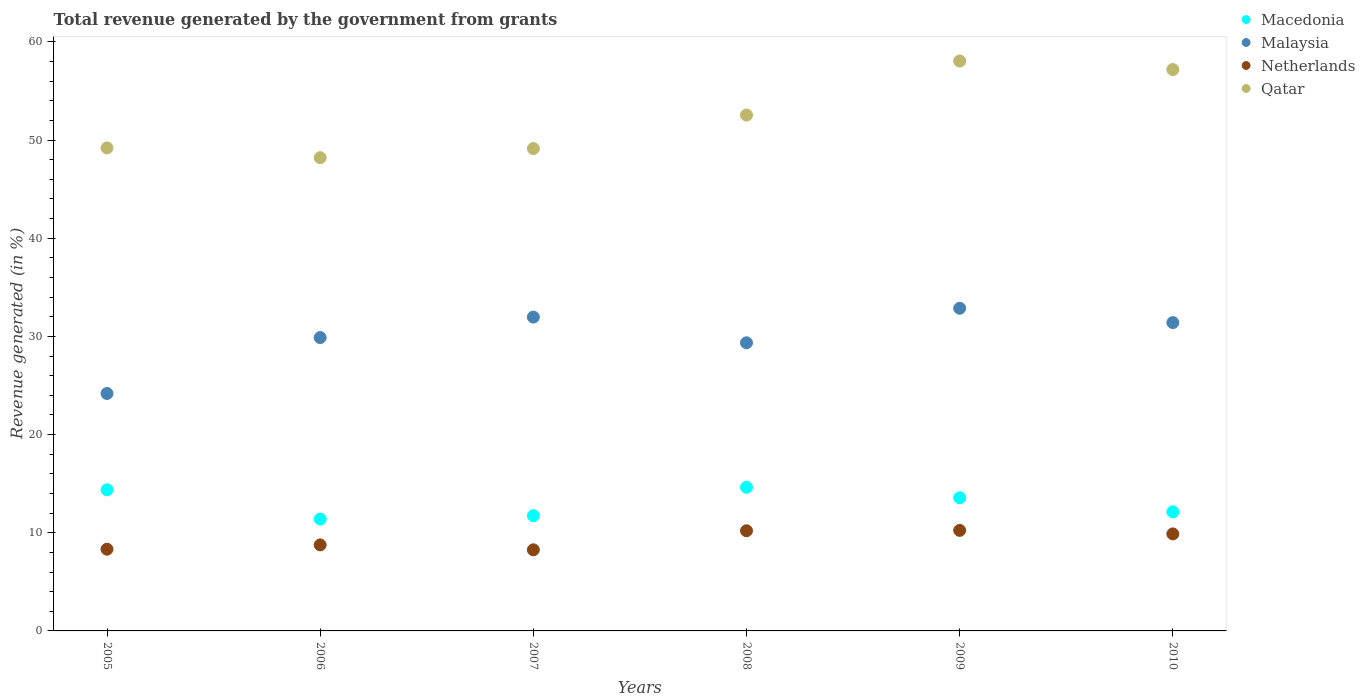What is the total revenue generated in Malaysia in 2009?
Keep it short and to the point. 32.86. Across all years, what is the maximum total revenue generated in Malaysia?
Offer a very short reply. 32.86. Across all years, what is the minimum total revenue generated in Qatar?
Give a very brief answer. 48.2. What is the total total revenue generated in Malaysia in the graph?
Provide a short and direct response. 179.65. What is the difference between the total revenue generated in Netherlands in 2005 and that in 2008?
Provide a short and direct response. -1.88. What is the difference between the total revenue generated in Qatar in 2007 and the total revenue generated in Netherlands in 2009?
Keep it short and to the point. 38.89. What is the average total revenue generated in Macedonia per year?
Make the answer very short. 12.97. In the year 2009, what is the difference between the total revenue generated in Qatar and total revenue generated in Macedonia?
Your answer should be compact. 44.49. In how many years, is the total revenue generated in Malaysia greater than 58 %?
Ensure brevity in your answer.  0. What is the ratio of the total revenue generated in Qatar in 2005 to that in 2010?
Offer a terse response. 0.86. Is the total revenue generated in Malaysia in 2006 less than that in 2008?
Offer a very short reply. No. What is the difference between the highest and the second highest total revenue generated in Malaysia?
Give a very brief answer. 0.9. What is the difference between the highest and the lowest total revenue generated in Malaysia?
Provide a short and direct response. 8.68. Is it the case that in every year, the sum of the total revenue generated in Qatar and total revenue generated in Malaysia  is greater than the sum of total revenue generated in Macedonia and total revenue generated in Netherlands?
Offer a terse response. Yes. Is it the case that in every year, the sum of the total revenue generated in Macedonia and total revenue generated in Malaysia  is greater than the total revenue generated in Qatar?
Ensure brevity in your answer.  No. Is the total revenue generated in Malaysia strictly less than the total revenue generated in Qatar over the years?
Offer a very short reply. Yes. How many dotlines are there?
Keep it short and to the point. 4. How many years are there in the graph?
Ensure brevity in your answer.  6. Are the values on the major ticks of Y-axis written in scientific E-notation?
Your response must be concise. No. Does the graph contain any zero values?
Keep it short and to the point. No. Does the graph contain grids?
Provide a short and direct response. No. What is the title of the graph?
Offer a terse response. Total revenue generated by the government from grants. Does "Guyana" appear as one of the legend labels in the graph?
Offer a very short reply. No. What is the label or title of the Y-axis?
Make the answer very short. Revenue generated (in %). What is the Revenue generated (in %) in Macedonia in 2005?
Your answer should be compact. 14.38. What is the Revenue generated (in %) of Malaysia in 2005?
Offer a very short reply. 24.19. What is the Revenue generated (in %) of Netherlands in 2005?
Ensure brevity in your answer.  8.33. What is the Revenue generated (in %) of Qatar in 2005?
Your response must be concise. 49.2. What is the Revenue generated (in %) of Macedonia in 2006?
Offer a very short reply. 11.39. What is the Revenue generated (in %) of Malaysia in 2006?
Offer a terse response. 29.88. What is the Revenue generated (in %) in Netherlands in 2006?
Give a very brief answer. 8.76. What is the Revenue generated (in %) in Qatar in 2006?
Provide a succinct answer. 48.2. What is the Revenue generated (in %) of Macedonia in 2007?
Your response must be concise. 11.74. What is the Revenue generated (in %) in Malaysia in 2007?
Give a very brief answer. 31.97. What is the Revenue generated (in %) of Netherlands in 2007?
Provide a succinct answer. 8.26. What is the Revenue generated (in %) in Qatar in 2007?
Your response must be concise. 49.13. What is the Revenue generated (in %) in Macedonia in 2008?
Provide a succinct answer. 14.63. What is the Revenue generated (in %) in Malaysia in 2008?
Provide a short and direct response. 29.35. What is the Revenue generated (in %) of Netherlands in 2008?
Make the answer very short. 10.2. What is the Revenue generated (in %) of Qatar in 2008?
Your response must be concise. 52.54. What is the Revenue generated (in %) in Macedonia in 2009?
Provide a short and direct response. 13.56. What is the Revenue generated (in %) in Malaysia in 2009?
Ensure brevity in your answer.  32.86. What is the Revenue generated (in %) of Netherlands in 2009?
Offer a terse response. 10.24. What is the Revenue generated (in %) of Qatar in 2009?
Keep it short and to the point. 58.05. What is the Revenue generated (in %) of Macedonia in 2010?
Offer a very short reply. 12.13. What is the Revenue generated (in %) in Malaysia in 2010?
Give a very brief answer. 31.4. What is the Revenue generated (in %) in Netherlands in 2010?
Provide a succinct answer. 9.88. What is the Revenue generated (in %) of Qatar in 2010?
Your response must be concise. 57.18. Across all years, what is the maximum Revenue generated (in %) in Macedonia?
Make the answer very short. 14.63. Across all years, what is the maximum Revenue generated (in %) in Malaysia?
Your answer should be very brief. 32.86. Across all years, what is the maximum Revenue generated (in %) in Netherlands?
Offer a terse response. 10.24. Across all years, what is the maximum Revenue generated (in %) in Qatar?
Keep it short and to the point. 58.05. Across all years, what is the minimum Revenue generated (in %) in Macedonia?
Offer a terse response. 11.39. Across all years, what is the minimum Revenue generated (in %) of Malaysia?
Your answer should be compact. 24.19. Across all years, what is the minimum Revenue generated (in %) in Netherlands?
Your response must be concise. 8.26. Across all years, what is the minimum Revenue generated (in %) in Qatar?
Provide a succinct answer. 48.2. What is the total Revenue generated (in %) of Macedonia in the graph?
Keep it short and to the point. 77.83. What is the total Revenue generated (in %) in Malaysia in the graph?
Keep it short and to the point. 179.65. What is the total Revenue generated (in %) in Netherlands in the graph?
Offer a terse response. 55.67. What is the total Revenue generated (in %) of Qatar in the graph?
Provide a short and direct response. 314.31. What is the difference between the Revenue generated (in %) in Macedonia in 2005 and that in 2006?
Give a very brief answer. 2.98. What is the difference between the Revenue generated (in %) of Malaysia in 2005 and that in 2006?
Give a very brief answer. -5.69. What is the difference between the Revenue generated (in %) of Netherlands in 2005 and that in 2006?
Give a very brief answer. -0.44. What is the difference between the Revenue generated (in %) in Macedonia in 2005 and that in 2007?
Provide a succinct answer. 2.64. What is the difference between the Revenue generated (in %) in Malaysia in 2005 and that in 2007?
Give a very brief answer. -7.78. What is the difference between the Revenue generated (in %) of Netherlands in 2005 and that in 2007?
Your answer should be very brief. 0.06. What is the difference between the Revenue generated (in %) in Qatar in 2005 and that in 2007?
Make the answer very short. 0.06. What is the difference between the Revenue generated (in %) in Macedonia in 2005 and that in 2008?
Make the answer very short. -0.25. What is the difference between the Revenue generated (in %) of Malaysia in 2005 and that in 2008?
Give a very brief answer. -5.16. What is the difference between the Revenue generated (in %) of Netherlands in 2005 and that in 2008?
Provide a short and direct response. -1.88. What is the difference between the Revenue generated (in %) in Qatar in 2005 and that in 2008?
Make the answer very short. -3.35. What is the difference between the Revenue generated (in %) of Macedonia in 2005 and that in 2009?
Provide a short and direct response. 0.82. What is the difference between the Revenue generated (in %) of Malaysia in 2005 and that in 2009?
Make the answer very short. -8.68. What is the difference between the Revenue generated (in %) of Netherlands in 2005 and that in 2009?
Give a very brief answer. -1.91. What is the difference between the Revenue generated (in %) of Qatar in 2005 and that in 2009?
Offer a terse response. -8.85. What is the difference between the Revenue generated (in %) in Macedonia in 2005 and that in 2010?
Provide a succinct answer. 2.24. What is the difference between the Revenue generated (in %) in Malaysia in 2005 and that in 2010?
Your answer should be compact. -7.22. What is the difference between the Revenue generated (in %) in Netherlands in 2005 and that in 2010?
Your answer should be very brief. -1.56. What is the difference between the Revenue generated (in %) in Qatar in 2005 and that in 2010?
Your answer should be compact. -7.98. What is the difference between the Revenue generated (in %) of Macedonia in 2006 and that in 2007?
Keep it short and to the point. -0.35. What is the difference between the Revenue generated (in %) of Malaysia in 2006 and that in 2007?
Your answer should be very brief. -2.09. What is the difference between the Revenue generated (in %) of Netherlands in 2006 and that in 2007?
Keep it short and to the point. 0.5. What is the difference between the Revenue generated (in %) in Qatar in 2006 and that in 2007?
Provide a succinct answer. -0.93. What is the difference between the Revenue generated (in %) of Macedonia in 2006 and that in 2008?
Make the answer very short. -3.24. What is the difference between the Revenue generated (in %) in Malaysia in 2006 and that in 2008?
Offer a terse response. 0.53. What is the difference between the Revenue generated (in %) of Netherlands in 2006 and that in 2008?
Your answer should be very brief. -1.44. What is the difference between the Revenue generated (in %) in Qatar in 2006 and that in 2008?
Ensure brevity in your answer.  -4.34. What is the difference between the Revenue generated (in %) of Macedonia in 2006 and that in 2009?
Make the answer very short. -2.17. What is the difference between the Revenue generated (in %) of Malaysia in 2006 and that in 2009?
Make the answer very short. -2.98. What is the difference between the Revenue generated (in %) in Netherlands in 2006 and that in 2009?
Your answer should be compact. -1.48. What is the difference between the Revenue generated (in %) in Qatar in 2006 and that in 2009?
Make the answer very short. -9.85. What is the difference between the Revenue generated (in %) of Macedonia in 2006 and that in 2010?
Your answer should be compact. -0.74. What is the difference between the Revenue generated (in %) in Malaysia in 2006 and that in 2010?
Provide a succinct answer. -1.52. What is the difference between the Revenue generated (in %) of Netherlands in 2006 and that in 2010?
Your answer should be very brief. -1.12. What is the difference between the Revenue generated (in %) of Qatar in 2006 and that in 2010?
Your answer should be very brief. -8.98. What is the difference between the Revenue generated (in %) of Macedonia in 2007 and that in 2008?
Provide a short and direct response. -2.89. What is the difference between the Revenue generated (in %) of Malaysia in 2007 and that in 2008?
Offer a terse response. 2.62. What is the difference between the Revenue generated (in %) in Netherlands in 2007 and that in 2008?
Provide a succinct answer. -1.94. What is the difference between the Revenue generated (in %) of Qatar in 2007 and that in 2008?
Keep it short and to the point. -3.41. What is the difference between the Revenue generated (in %) in Macedonia in 2007 and that in 2009?
Offer a very short reply. -1.82. What is the difference between the Revenue generated (in %) in Malaysia in 2007 and that in 2009?
Keep it short and to the point. -0.9. What is the difference between the Revenue generated (in %) of Netherlands in 2007 and that in 2009?
Give a very brief answer. -1.98. What is the difference between the Revenue generated (in %) in Qatar in 2007 and that in 2009?
Offer a terse response. -8.92. What is the difference between the Revenue generated (in %) in Macedonia in 2007 and that in 2010?
Give a very brief answer. -0.39. What is the difference between the Revenue generated (in %) in Malaysia in 2007 and that in 2010?
Your answer should be compact. 0.56. What is the difference between the Revenue generated (in %) in Netherlands in 2007 and that in 2010?
Provide a succinct answer. -1.62. What is the difference between the Revenue generated (in %) of Qatar in 2007 and that in 2010?
Keep it short and to the point. -8.05. What is the difference between the Revenue generated (in %) in Macedonia in 2008 and that in 2009?
Your answer should be compact. 1.07. What is the difference between the Revenue generated (in %) in Malaysia in 2008 and that in 2009?
Provide a short and direct response. -3.52. What is the difference between the Revenue generated (in %) of Netherlands in 2008 and that in 2009?
Give a very brief answer. -0.04. What is the difference between the Revenue generated (in %) of Qatar in 2008 and that in 2009?
Your response must be concise. -5.51. What is the difference between the Revenue generated (in %) in Macedonia in 2008 and that in 2010?
Your answer should be compact. 2.5. What is the difference between the Revenue generated (in %) of Malaysia in 2008 and that in 2010?
Provide a succinct answer. -2.06. What is the difference between the Revenue generated (in %) in Netherlands in 2008 and that in 2010?
Ensure brevity in your answer.  0.32. What is the difference between the Revenue generated (in %) in Qatar in 2008 and that in 2010?
Provide a short and direct response. -4.64. What is the difference between the Revenue generated (in %) of Macedonia in 2009 and that in 2010?
Keep it short and to the point. 1.43. What is the difference between the Revenue generated (in %) of Malaysia in 2009 and that in 2010?
Provide a succinct answer. 1.46. What is the difference between the Revenue generated (in %) in Netherlands in 2009 and that in 2010?
Make the answer very short. 0.36. What is the difference between the Revenue generated (in %) in Qatar in 2009 and that in 2010?
Give a very brief answer. 0.87. What is the difference between the Revenue generated (in %) in Macedonia in 2005 and the Revenue generated (in %) in Malaysia in 2006?
Your response must be concise. -15.5. What is the difference between the Revenue generated (in %) of Macedonia in 2005 and the Revenue generated (in %) of Netherlands in 2006?
Make the answer very short. 5.61. What is the difference between the Revenue generated (in %) in Macedonia in 2005 and the Revenue generated (in %) in Qatar in 2006?
Provide a short and direct response. -33.83. What is the difference between the Revenue generated (in %) in Malaysia in 2005 and the Revenue generated (in %) in Netherlands in 2006?
Offer a terse response. 15.42. What is the difference between the Revenue generated (in %) in Malaysia in 2005 and the Revenue generated (in %) in Qatar in 2006?
Offer a terse response. -24.02. What is the difference between the Revenue generated (in %) of Netherlands in 2005 and the Revenue generated (in %) of Qatar in 2006?
Provide a succinct answer. -39.88. What is the difference between the Revenue generated (in %) of Macedonia in 2005 and the Revenue generated (in %) of Malaysia in 2007?
Provide a succinct answer. -17.59. What is the difference between the Revenue generated (in %) in Macedonia in 2005 and the Revenue generated (in %) in Netherlands in 2007?
Offer a very short reply. 6.11. What is the difference between the Revenue generated (in %) of Macedonia in 2005 and the Revenue generated (in %) of Qatar in 2007?
Give a very brief answer. -34.76. What is the difference between the Revenue generated (in %) in Malaysia in 2005 and the Revenue generated (in %) in Netherlands in 2007?
Provide a succinct answer. 15.92. What is the difference between the Revenue generated (in %) of Malaysia in 2005 and the Revenue generated (in %) of Qatar in 2007?
Your answer should be compact. -24.95. What is the difference between the Revenue generated (in %) in Netherlands in 2005 and the Revenue generated (in %) in Qatar in 2007?
Provide a short and direct response. -40.81. What is the difference between the Revenue generated (in %) of Macedonia in 2005 and the Revenue generated (in %) of Malaysia in 2008?
Give a very brief answer. -14.97. What is the difference between the Revenue generated (in %) in Macedonia in 2005 and the Revenue generated (in %) in Netherlands in 2008?
Keep it short and to the point. 4.17. What is the difference between the Revenue generated (in %) of Macedonia in 2005 and the Revenue generated (in %) of Qatar in 2008?
Give a very brief answer. -38.17. What is the difference between the Revenue generated (in %) in Malaysia in 2005 and the Revenue generated (in %) in Netherlands in 2008?
Provide a succinct answer. 13.98. What is the difference between the Revenue generated (in %) in Malaysia in 2005 and the Revenue generated (in %) in Qatar in 2008?
Give a very brief answer. -28.36. What is the difference between the Revenue generated (in %) in Netherlands in 2005 and the Revenue generated (in %) in Qatar in 2008?
Give a very brief answer. -44.22. What is the difference between the Revenue generated (in %) in Macedonia in 2005 and the Revenue generated (in %) in Malaysia in 2009?
Ensure brevity in your answer.  -18.49. What is the difference between the Revenue generated (in %) of Macedonia in 2005 and the Revenue generated (in %) of Netherlands in 2009?
Provide a short and direct response. 4.14. What is the difference between the Revenue generated (in %) in Macedonia in 2005 and the Revenue generated (in %) in Qatar in 2009?
Your answer should be very brief. -43.67. What is the difference between the Revenue generated (in %) of Malaysia in 2005 and the Revenue generated (in %) of Netherlands in 2009?
Your response must be concise. 13.95. What is the difference between the Revenue generated (in %) in Malaysia in 2005 and the Revenue generated (in %) in Qatar in 2009?
Provide a succinct answer. -33.86. What is the difference between the Revenue generated (in %) of Netherlands in 2005 and the Revenue generated (in %) of Qatar in 2009?
Provide a short and direct response. -49.72. What is the difference between the Revenue generated (in %) in Macedonia in 2005 and the Revenue generated (in %) in Malaysia in 2010?
Your response must be concise. -17.03. What is the difference between the Revenue generated (in %) of Macedonia in 2005 and the Revenue generated (in %) of Netherlands in 2010?
Provide a succinct answer. 4.49. What is the difference between the Revenue generated (in %) in Macedonia in 2005 and the Revenue generated (in %) in Qatar in 2010?
Provide a short and direct response. -42.8. What is the difference between the Revenue generated (in %) in Malaysia in 2005 and the Revenue generated (in %) in Netherlands in 2010?
Make the answer very short. 14.3. What is the difference between the Revenue generated (in %) of Malaysia in 2005 and the Revenue generated (in %) of Qatar in 2010?
Your answer should be compact. -32.99. What is the difference between the Revenue generated (in %) in Netherlands in 2005 and the Revenue generated (in %) in Qatar in 2010?
Provide a succinct answer. -48.86. What is the difference between the Revenue generated (in %) of Macedonia in 2006 and the Revenue generated (in %) of Malaysia in 2007?
Your answer should be compact. -20.57. What is the difference between the Revenue generated (in %) in Macedonia in 2006 and the Revenue generated (in %) in Netherlands in 2007?
Provide a short and direct response. 3.13. What is the difference between the Revenue generated (in %) in Macedonia in 2006 and the Revenue generated (in %) in Qatar in 2007?
Give a very brief answer. -37.74. What is the difference between the Revenue generated (in %) in Malaysia in 2006 and the Revenue generated (in %) in Netherlands in 2007?
Offer a very short reply. 21.62. What is the difference between the Revenue generated (in %) of Malaysia in 2006 and the Revenue generated (in %) of Qatar in 2007?
Make the answer very short. -19.25. What is the difference between the Revenue generated (in %) in Netherlands in 2006 and the Revenue generated (in %) in Qatar in 2007?
Your answer should be very brief. -40.37. What is the difference between the Revenue generated (in %) of Macedonia in 2006 and the Revenue generated (in %) of Malaysia in 2008?
Your response must be concise. -17.96. What is the difference between the Revenue generated (in %) in Macedonia in 2006 and the Revenue generated (in %) in Netherlands in 2008?
Give a very brief answer. 1.19. What is the difference between the Revenue generated (in %) in Macedonia in 2006 and the Revenue generated (in %) in Qatar in 2008?
Give a very brief answer. -41.15. What is the difference between the Revenue generated (in %) of Malaysia in 2006 and the Revenue generated (in %) of Netherlands in 2008?
Keep it short and to the point. 19.68. What is the difference between the Revenue generated (in %) in Malaysia in 2006 and the Revenue generated (in %) in Qatar in 2008?
Offer a terse response. -22.66. What is the difference between the Revenue generated (in %) in Netherlands in 2006 and the Revenue generated (in %) in Qatar in 2008?
Make the answer very short. -43.78. What is the difference between the Revenue generated (in %) of Macedonia in 2006 and the Revenue generated (in %) of Malaysia in 2009?
Your answer should be very brief. -21.47. What is the difference between the Revenue generated (in %) of Macedonia in 2006 and the Revenue generated (in %) of Netherlands in 2009?
Ensure brevity in your answer.  1.15. What is the difference between the Revenue generated (in %) of Macedonia in 2006 and the Revenue generated (in %) of Qatar in 2009?
Offer a very short reply. -46.66. What is the difference between the Revenue generated (in %) in Malaysia in 2006 and the Revenue generated (in %) in Netherlands in 2009?
Provide a short and direct response. 19.64. What is the difference between the Revenue generated (in %) in Malaysia in 2006 and the Revenue generated (in %) in Qatar in 2009?
Offer a terse response. -28.17. What is the difference between the Revenue generated (in %) in Netherlands in 2006 and the Revenue generated (in %) in Qatar in 2009?
Provide a succinct answer. -49.29. What is the difference between the Revenue generated (in %) of Macedonia in 2006 and the Revenue generated (in %) of Malaysia in 2010?
Provide a short and direct response. -20.01. What is the difference between the Revenue generated (in %) of Macedonia in 2006 and the Revenue generated (in %) of Netherlands in 2010?
Give a very brief answer. 1.51. What is the difference between the Revenue generated (in %) of Macedonia in 2006 and the Revenue generated (in %) of Qatar in 2010?
Provide a short and direct response. -45.79. What is the difference between the Revenue generated (in %) of Malaysia in 2006 and the Revenue generated (in %) of Netherlands in 2010?
Offer a terse response. 20. What is the difference between the Revenue generated (in %) of Malaysia in 2006 and the Revenue generated (in %) of Qatar in 2010?
Provide a succinct answer. -27.3. What is the difference between the Revenue generated (in %) in Netherlands in 2006 and the Revenue generated (in %) in Qatar in 2010?
Make the answer very short. -48.42. What is the difference between the Revenue generated (in %) in Macedonia in 2007 and the Revenue generated (in %) in Malaysia in 2008?
Make the answer very short. -17.61. What is the difference between the Revenue generated (in %) in Macedonia in 2007 and the Revenue generated (in %) in Netherlands in 2008?
Give a very brief answer. 1.54. What is the difference between the Revenue generated (in %) in Macedonia in 2007 and the Revenue generated (in %) in Qatar in 2008?
Your response must be concise. -40.81. What is the difference between the Revenue generated (in %) of Malaysia in 2007 and the Revenue generated (in %) of Netherlands in 2008?
Offer a very short reply. 21.77. What is the difference between the Revenue generated (in %) of Malaysia in 2007 and the Revenue generated (in %) of Qatar in 2008?
Keep it short and to the point. -20.58. What is the difference between the Revenue generated (in %) in Netherlands in 2007 and the Revenue generated (in %) in Qatar in 2008?
Ensure brevity in your answer.  -44.28. What is the difference between the Revenue generated (in %) of Macedonia in 2007 and the Revenue generated (in %) of Malaysia in 2009?
Make the answer very short. -21.13. What is the difference between the Revenue generated (in %) in Macedonia in 2007 and the Revenue generated (in %) in Netherlands in 2009?
Give a very brief answer. 1.5. What is the difference between the Revenue generated (in %) in Macedonia in 2007 and the Revenue generated (in %) in Qatar in 2009?
Offer a terse response. -46.31. What is the difference between the Revenue generated (in %) of Malaysia in 2007 and the Revenue generated (in %) of Netherlands in 2009?
Offer a very short reply. 21.73. What is the difference between the Revenue generated (in %) in Malaysia in 2007 and the Revenue generated (in %) in Qatar in 2009?
Provide a short and direct response. -26.08. What is the difference between the Revenue generated (in %) of Netherlands in 2007 and the Revenue generated (in %) of Qatar in 2009?
Provide a succinct answer. -49.79. What is the difference between the Revenue generated (in %) in Macedonia in 2007 and the Revenue generated (in %) in Malaysia in 2010?
Offer a very short reply. -19.67. What is the difference between the Revenue generated (in %) of Macedonia in 2007 and the Revenue generated (in %) of Netherlands in 2010?
Offer a very short reply. 1.85. What is the difference between the Revenue generated (in %) of Macedonia in 2007 and the Revenue generated (in %) of Qatar in 2010?
Offer a very short reply. -45.44. What is the difference between the Revenue generated (in %) in Malaysia in 2007 and the Revenue generated (in %) in Netherlands in 2010?
Ensure brevity in your answer.  22.08. What is the difference between the Revenue generated (in %) in Malaysia in 2007 and the Revenue generated (in %) in Qatar in 2010?
Offer a terse response. -25.21. What is the difference between the Revenue generated (in %) in Netherlands in 2007 and the Revenue generated (in %) in Qatar in 2010?
Offer a very short reply. -48.92. What is the difference between the Revenue generated (in %) of Macedonia in 2008 and the Revenue generated (in %) of Malaysia in 2009?
Give a very brief answer. -18.23. What is the difference between the Revenue generated (in %) in Macedonia in 2008 and the Revenue generated (in %) in Netherlands in 2009?
Your answer should be compact. 4.39. What is the difference between the Revenue generated (in %) in Macedonia in 2008 and the Revenue generated (in %) in Qatar in 2009?
Give a very brief answer. -43.42. What is the difference between the Revenue generated (in %) in Malaysia in 2008 and the Revenue generated (in %) in Netherlands in 2009?
Make the answer very short. 19.11. What is the difference between the Revenue generated (in %) of Malaysia in 2008 and the Revenue generated (in %) of Qatar in 2009?
Your answer should be very brief. -28.7. What is the difference between the Revenue generated (in %) in Netherlands in 2008 and the Revenue generated (in %) in Qatar in 2009?
Provide a short and direct response. -47.85. What is the difference between the Revenue generated (in %) in Macedonia in 2008 and the Revenue generated (in %) in Malaysia in 2010?
Give a very brief answer. -16.77. What is the difference between the Revenue generated (in %) in Macedonia in 2008 and the Revenue generated (in %) in Netherlands in 2010?
Make the answer very short. 4.75. What is the difference between the Revenue generated (in %) of Macedonia in 2008 and the Revenue generated (in %) of Qatar in 2010?
Your response must be concise. -42.55. What is the difference between the Revenue generated (in %) of Malaysia in 2008 and the Revenue generated (in %) of Netherlands in 2010?
Offer a terse response. 19.47. What is the difference between the Revenue generated (in %) of Malaysia in 2008 and the Revenue generated (in %) of Qatar in 2010?
Your answer should be very brief. -27.83. What is the difference between the Revenue generated (in %) of Netherlands in 2008 and the Revenue generated (in %) of Qatar in 2010?
Provide a short and direct response. -46.98. What is the difference between the Revenue generated (in %) of Macedonia in 2009 and the Revenue generated (in %) of Malaysia in 2010?
Keep it short and to the point. -17.84. What is the difference between the Revenue generated (in %) in Macedonia in 2009 and the Revenue generated (in %) in Netherlands in 2010?
Offer a very short reply. 3.68. What is the difference between the Revenue generated (in %) of Macedonia in 2009 and the Revenue generated (in %) of Qatar in 2010?
Offer a terse response. -43.62. What is the difference between the Revenue generated (in %) in Malaysia in 2009 and the Revenue generated (in %) in Netherlands in 2010?
Keep it short and to the point. 22.98. What is the difference between the Revenue generated (in %) in Malaysia in 2009 and the Revenue generated (in %) in Qatar in 2010?
Ensure brevity in your answer.  -24.32. What is the difference between the Revenue generated (in %) of Netherlands in 2009 and the Revenue generated (in %) of Qatar in 2010?
Give a very brief answer. -46.94. What is the average Revenue generated (in %) in Macedonia per year?
Keep it short and to the point. 12.97. What is the average Revenue generated (in %) of Malaysia per year?
Make the answer very short. 29.94. What is the average Revenue generated (in %) in Netherlands per year?
Provide a succinct answer. 9.28. What is the average Revenue generated (in %) in Qatar per year?
Offer a very short reply. 52.38. In the year 2005, what is the difference between the Revenue generated (in %) in Macedonia and Revenue generated (in %) in Malaysia?
Make the answer very short. -9.81. In the year 2005, what is the difference between the Revenue generated (in %) of Macedonia and Revenue generated (in %) of Netherlands?
Your answer should be compact. 6.05. In the year 2005, what is the difference between the Revenue generated (in %) of Macedonia and Revenue generated (in %) of Qatar?
Provide a short and direct response. -34.82. In the year 2005, what is the difference between the Revenue generated (in %) of Malaysia and Revenue generated (in %) of Netherlands?
Give a very brief answer. 15.86. In the year 2005, what is the difference between the Revenue generated (in %) in Malaysia and Revenue generated (in %) in Qatar?
Give a very brief answer. -25.01. In the year 2005, what is the difference between the Revenue generated (in %) of Netherlands and Revenue generated (in %) of Qatar?
Give a very brief answer. -40.87. In the year 2006, what is the difference between the Revenue generated (in %) of Macedonia and Revenue generated (in %) of Malaysia?
Provide a succinct answer. -18.49. In the year 2006, what is the difference between the Revenue generated (in %) in Macedonia and Revenue generated (in %) in Netherlands?
Your answer should be very brief. 2.63. In the year 2006, what is the difference between the Revenue generated (in %) of Macedonia and Revenue generated (in %) of Qatar?
Give a very brief answer. -36.81. In the year 2006, what is the difference between the Revenue generated (in %) in Malaysia and Revenue generated (in %) in Netherlands?
Offer a terse response. 21.12. In the year 2006, what is the difference between the Revenue generated (in %) in Malaysia and Revenue generated (in %) in Qatar?
Your answer should be very brief. -18.32. In the year 2006, what is the difference between the Revenue generated (in %) in Netherlands and Revenue generated (in %) in Qatar?
Make the answer very short. -39.44. In the year 2007, what is the difference between the Revenue generated (in %) of Macedonia and Revenue generated (in %) of Malaysia?
Provide a succinct answer. -20.23. In the year 2007, what is the difference between the Revenue generated (in %) of Macedonia and Revenue generated (in %) of Netherlands?
Your answer should be very brief. 3.48. In the year 2007, what is the difference between the Revenue generated (in %) of Macedonia and Revenue generated (in %) of Qatar?
Give a very brief answer. -37.4. In the year 2007, what is the difference between the Revenue generated (in %) of Malaysia and Revenue generated (in %) of Netherlands?
Your response must be concise. 23.71. In the year 2007, what is the difference between the Revenue generated (in %) in Malaysia and Revenue generated (in %) in Qatar?
Provide a succinct answer. -17.17. In the year 2007, what is the difference between the Revenue generated (in %) of Netherlands and Revenue generated (in %) of Qatar?
Provide a short and direct response. -40.87. In the year 2008, what is the difference between the Revenue generated (in %) of Macedonia and Revenue generated (in %) of Malaysia?
Keep it short and to the point. -14.72. In the year 2008, what is the difference between the Revenue generated (in %) of Macedonia and Revenue generated (in %) of Netherlands?
Ensure brevity in your answer.  4.43. In the year 2008, what is the difference between the Revenue generated (in %) in Macedonia and Revenue generated (in %) in Qatar?
Your answer should be very brief. -37.91. In the year 2008, what is the difference between the Revenue generated (in %) of Malaysia and Revenue generated (in %) of Netherlands?
Keep it short and to the point. 19.15. In the year 2008, what is the difference between the Revenue generated (in %) in Malaysia and Revenue generated (in %) in Qatar?
Provide a short and direct response. -23.2. In the year 2008, what is the difference between the Revenue generated (in %) in Netherlands and Revenue generated (in %) in Qatar?
Give a very brief answer. -42.34. In the year 2009, what is the difference between the Revenue generated (in %) of Macedonia and Revenue generated (in %) of Malaysia?
Your answer should be very brief. -19.3. In the year 2009, what is the difference between the Revenue generated (in %) of Macedonia and Revenue generated (in %) of Netherlands?
Provide a short and direct response. 3.32. In the year 2009, what is the difference between the Revenue generated (in %) in Macedonia and Revenue generated (in %) in Qatar?
Your answer should be very brief. -44.49. In the year 2009, what is the difference between the Revenue generated (in %) of Malaysia and Revenue generated (in %) of Netherlands?
Your response must be concise. 22.62. In the year 2009, what is the difference between the Revenue generated (in %) in Malaysia and Revenue generated (in %) in Qatar?
Offer a very short reply. -25.19. In the year 2009, what is the difference between the Revenue generated (in %) in Netherlands and Revenue generated (in %) in Qatar?
Give a very brief answer. -47.81. In the year 2010, what is the difference between the Revenue generated (in %) in Macedonia and Revenue generated (in %) in Malaysia?
Give a very brief answer. -19.27. In the year 2010, what is the difference between the Revenue generated (in %) of Macedonia and Revenue generated (in %) of Netherlands?
Your answer should be compact. 2.25. In the year 2010, what is the difference between the Revenue generated (in %) of Macedonia and Revenue generated (in %) of Qatar?
Your answer should be very brief. -45.05. In the year 2010, what is the difference between the Revenue generated (in %) of Malaysia and Revenue generated (in %) of Netherlands?
Keep it short and to the point. 21.52. In the year 2010, what is the difference between the Revenue generated (in %) in Malaysia and Revenue generated (in %) in Qatar?
Offer a terse response. -25.78. In the year 2010, what is the difference between the Revenue generated (in %) in Netherlands and Revenue generated (in %) in Qatar?
Keep it short and to the point. -47.3. What is the ratio of the Revenue generated (in %) of Macedonia in 2005 to that in 2006?
Your answer should be compact. 1.26. What is the ratio of the Revenue generated (in %) of Malaysia in 2005 to that in 2006?
Provide a succinct answer. 0.81. What is the ratio of the Revenue generated (in %) in Netherlands in 2005 to that in 2006?
Keep it short and to the point. 0.95. What is the ratio of the Revenue generated (in %) of Qatar in 2005 to that in 2006?
Provide a succinct answer. 1.02. What is the ratio of the Revenue generated (in %) in Macedonia in 2005 to that in 2007?
Your answer should be compact. 1.22. What is the ratio of the Revenue generated (in %) of Malaysia in 2005 to that in 2007?
Your response must be concise. 0.76. What is the ratio of the Revenue generated (in %) in Netherlands in 2005 to that in 2007?
Your response must be concise. 1.01. What is the ratio of the Revenue generated (in %) in Macedonia in 2005 to that in 2008?
Provide a succinct answer. 0.98. What is the ratio of the Revenue generated (in %) of Malaysia in 2005 to that in 2008?
Your answer should be very brief. 0.82. What is the ratio of the Revenue generated (in %) in Netherlands in 2005 to that in 2008?
Your answer should be very brief. 0.82. What is the ratio of the Revenue generated (in %) in Qatar in 2005 to that in 2008?
Your answer should be compact. 0.94. What is the ratio of the Revenue generated (in %) of Macedonia in 2005 to that in 2009?
Give a very brief answer. 1.06. What is the ratio of the Revenue generated (in %) of Malaysia in 2005 to that in 2009?
Make the answer very short. 0.74. What is the ratio of the Revenue generated (in %) in Netherlands in 2005 to that in 2009?
Your answer should be compact. 0.81. What is the ratio of the Revenue generated (in %) in Qatar in 2005 to that in 2009?
Your response must be concise. 0.85. What is the ratio of the Revenue generated (in %) of Macedonia in 2005 to that in 2010?
Ensure brevity in your answer.  1.19. What is the ratio of the Revenue generated (in %) in Malaysia in 2005 to that in 2010?
Provide a succinct answer. 0.77. What is the ratio of the Revenue generated (in %) of Netherlands in 2005 to that in 2010?
Keep it short and to the point. 0.84. What is the ratio of the Revenue generated (in %) in Qatar in 2005 to that in 2010?
Give a very brief answer. 0.86. What is the ratio of the Revenue generated (in %) of Macedonia in 2006 to that in 2007?
Provide a short and direct response. 0.97. What is the ratio of the Revenue generated (in %) in Malaysia in 2006 to that in 2007?
Make the answer very short. 0.93. What is the ratio of the Revenue generated (in %) of Netherlands in 2006 to that in 2007?
Offer a very short reply. 1.06. What is the ratio of the Revenue generated (in %) in Qatar in 2006 to that in 2007?
Offer a very short reply. 0.98. What is the ratio of the Revenue generated (in %) of Macedonia in 2006 to that in 2008?
Keep it short and to the point. 0.78. What is the ratio of the Revenue generated (in %) in Malaysia in 2006 to that in 2008?
Offer a terse response. 1.02. What is the ratio of the Revenue generated (in %) of Netherlands in 2006 to that in 2008?
Ensure brevity in your answer.  0.86. What is the ratio of the Revenue generated (in %) in Qatar in 2006 to that in 2008?
Your response must be concise. 0.92. What is the ratio of the Revenue generated (in %) in Macedonia in 2006 to that in 2009?
Make the answer very short. 0.84. What is the ratio of the Revenue generated (in %) in Malaysia in 2006 to that in 2009?
Make the answer very short. 0.91. What is the ratio of the Revenue generated (in %) of Netherlands in 2006 to that in 2009?
Give a very brief answer. 0.86. What is the ratio of the Revenue generated (in %) of Qatar in 2006 to that in 2009?
Your answer should be very brief. 0.83. What is the ratio of the Revenue generated (in %) of Macedonia in 2006 to that in 2010?
Give a very brief answer. 0.94. What is the ratio of the Revenue generated (in %) in Malaysia in 2006 to that in 2010?
Provide a succinct answer. 0.95. What is the ratio of the Revenue generated (in %) of Netherlands in 2006 to that in 2010?
Keep it short and to the point. 0.89. What is the ratio of the Revenue generated (in %) in Qatar in 2006 to that in 2010?
Make the answer very short. 0.84. What is the ratio of the Revenue generated (in %) in Macedonia in 2007 to that in 2008?
Offer a terse response. 0.8. What is the ratio of the Revenue generated (in %) of Malaysia in 2007 to that in 2008?
Offer a very short reply. 1.09. What is the ratio of the Revenue generated (in %) in Netherlands in 2007 to that in 2008?
Keep it short and to the point. 0.81. What is the ratio of the Revenue generated (in %) of Qatar in 2007 to that in 2008?
Your response must be concise. 0.94. What is the ratio of the Revenue generated (in %) in Macedonia in 2007 to that in 2009?
Offer a very short reply. 0.87. What is the ratio of the Revenue generated (in %) of Malaysia in 2007 to that in 2009?
Your answer should be compact. 0.97. What is the ratio of the Revenue generated (in %) of Netherlands in 2007 to that in 2009?
Keep it short and to the point. 0.81. What is the ratio of the Revenue generated (in %) in Qatar in 2007 to that in 2009?
Your answer should be compact. 0.85. What is the ratio of the Revenue generated (in %) of Macedonia in 2007 to that in 2010?
Keep it short and to the point. 0.97. What is the ratio of the Revenue generated (in %) of Malaysia in 2007 to that in 2010?
Provide a short and direct response. 1.02. What is the ratio of the Revenue generated (in %) in Netherlands in 2007 to that in 2010?
Give a very brief answer. 0.84. What is the ratio of the Revenue generated (in %) of Qatar in 2007 to that in 2010?
Ensure brevity in your answer.  0.86. What is the ratio of the Revenue generated (in %) in Macedonia in 2008 to that in 2009?
Make the answer very short. 1.08. What is the ratio of the Revenue generated (in %) of Malaysia in 2008 to that in 2009?
Ensure brevity in your answer.  0.89. What is the ratio of the Revenue generated (in %) of Netherlands in 2008 to that in 2009?
Make the answer very short. 1. What is the ratio of the Revenue generated (in %) in Qatar in 2008 to that in 2009?
Your answer should be compact. 0.91. What is the ratio of the Revenue generated (in %) of Macedonia in 2008 to that in 2010?
Your answer should be compact. 1.21. What is the ratio of the Revenue generated (in %) in Malaysia in 2008 to that in 2010?
Provide a short and direct response. 0.93. What is the ratio of the Revenue generated (in %) in Netherlands in 2008 to that in 2010?
Make the answer very short. 1.03. What is the ratio of the Revenue generated (in %) in Qatar in 2008 to that in 2010?
Offer a very short reply. 0.92. What is the ratio of the Revenue generated (in %) in Macedonia in 2009 to that in 2010?
Provide a succinct answer. 1.12. What is the ratio of the Revenue generated (in %) of Malaysia in 2009 to that in 2010?
Make the answer very short. 1.05. What is the ratio of the Revenue generated (in %) in Netherlands in 2009 to that in 2010?
Make the answer very short. 1.04. What is the ratio of the Revenue generated (in %) in Qatar in 2009 to that in 2010?
Offer a terse response. 1.02. What is the difference between the highest and the second highest Revenue generated (in %) of Macedonia?
Your response must be concise. 0.25. What is the difference between the highest and the second highest Revenue generated (in %) in Malaysia?
Your answer should be very brief. 0.9. What is the difference between the highest and the second highest Revenue generated (in %) in Netherlands?
Provide a succinct answer. 0.04. What is the difference between the highest and the second highest Revenue generated (in %) in Qatar?
Offer a terse response. 0.87. What is the difference between the highest and the lowest Revenue generated (in %) in Macedonia?
Your answer should be compact. 3.24. What is the difference between the highest and the lowest Revenue generated (in %) of Malaysia?
Your answer should be very brief. 8.68. What is the difference between the highest and the lowest Revenue generated (in %) in Netherlands?
Offer a very short reply. 1.98. What is the difference between the highest and the lowest Revenue generated (in %) in Qatar?
Provide a succinct answer. 9.85. 